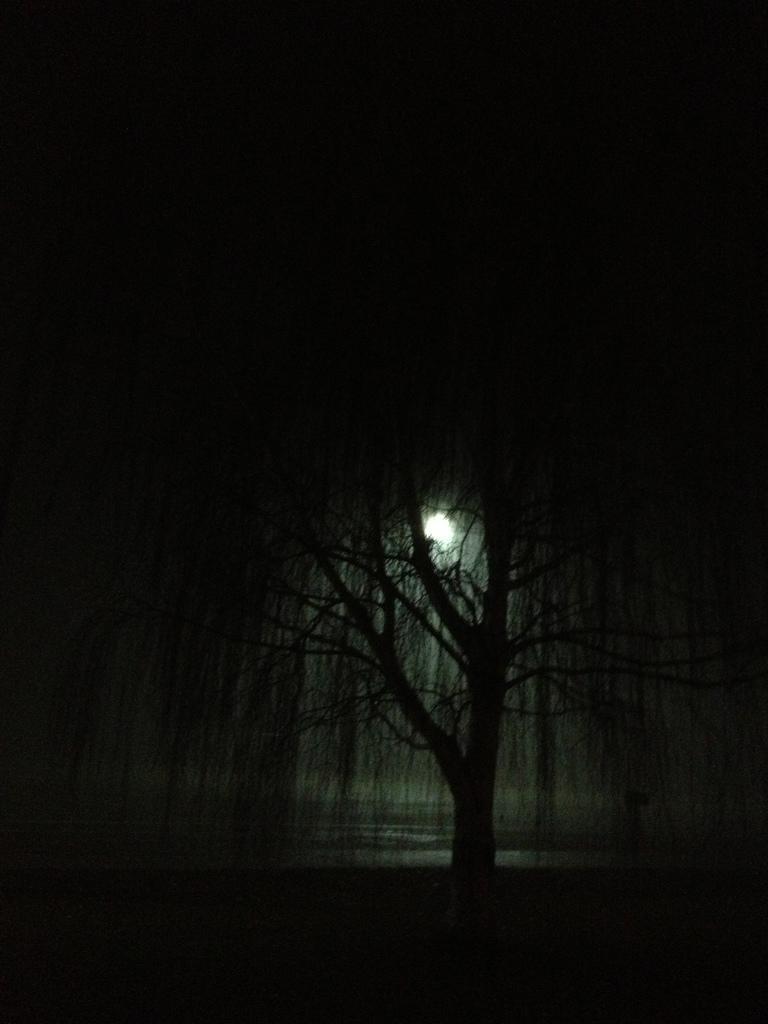In one or two sentences, can you explain what this image depicts? In this picture we can see a tree and in the background we can see it is dark. 